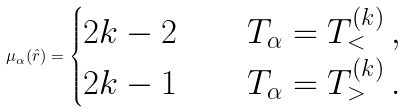<formula> <loc_0><loc_0><loc_500><loc_500>\mu _ { \alpha } ( \hat { r } ) = \begin{cases} 2 k - 2 & \quad T _ { \alpha } = T _ { < } ^ { ( k ) } \, , \\ 2 k - 1 & \quad T _ { \alpha } = T _ { > } ^ { ( k ) } \, . \end{cases}</formula> 